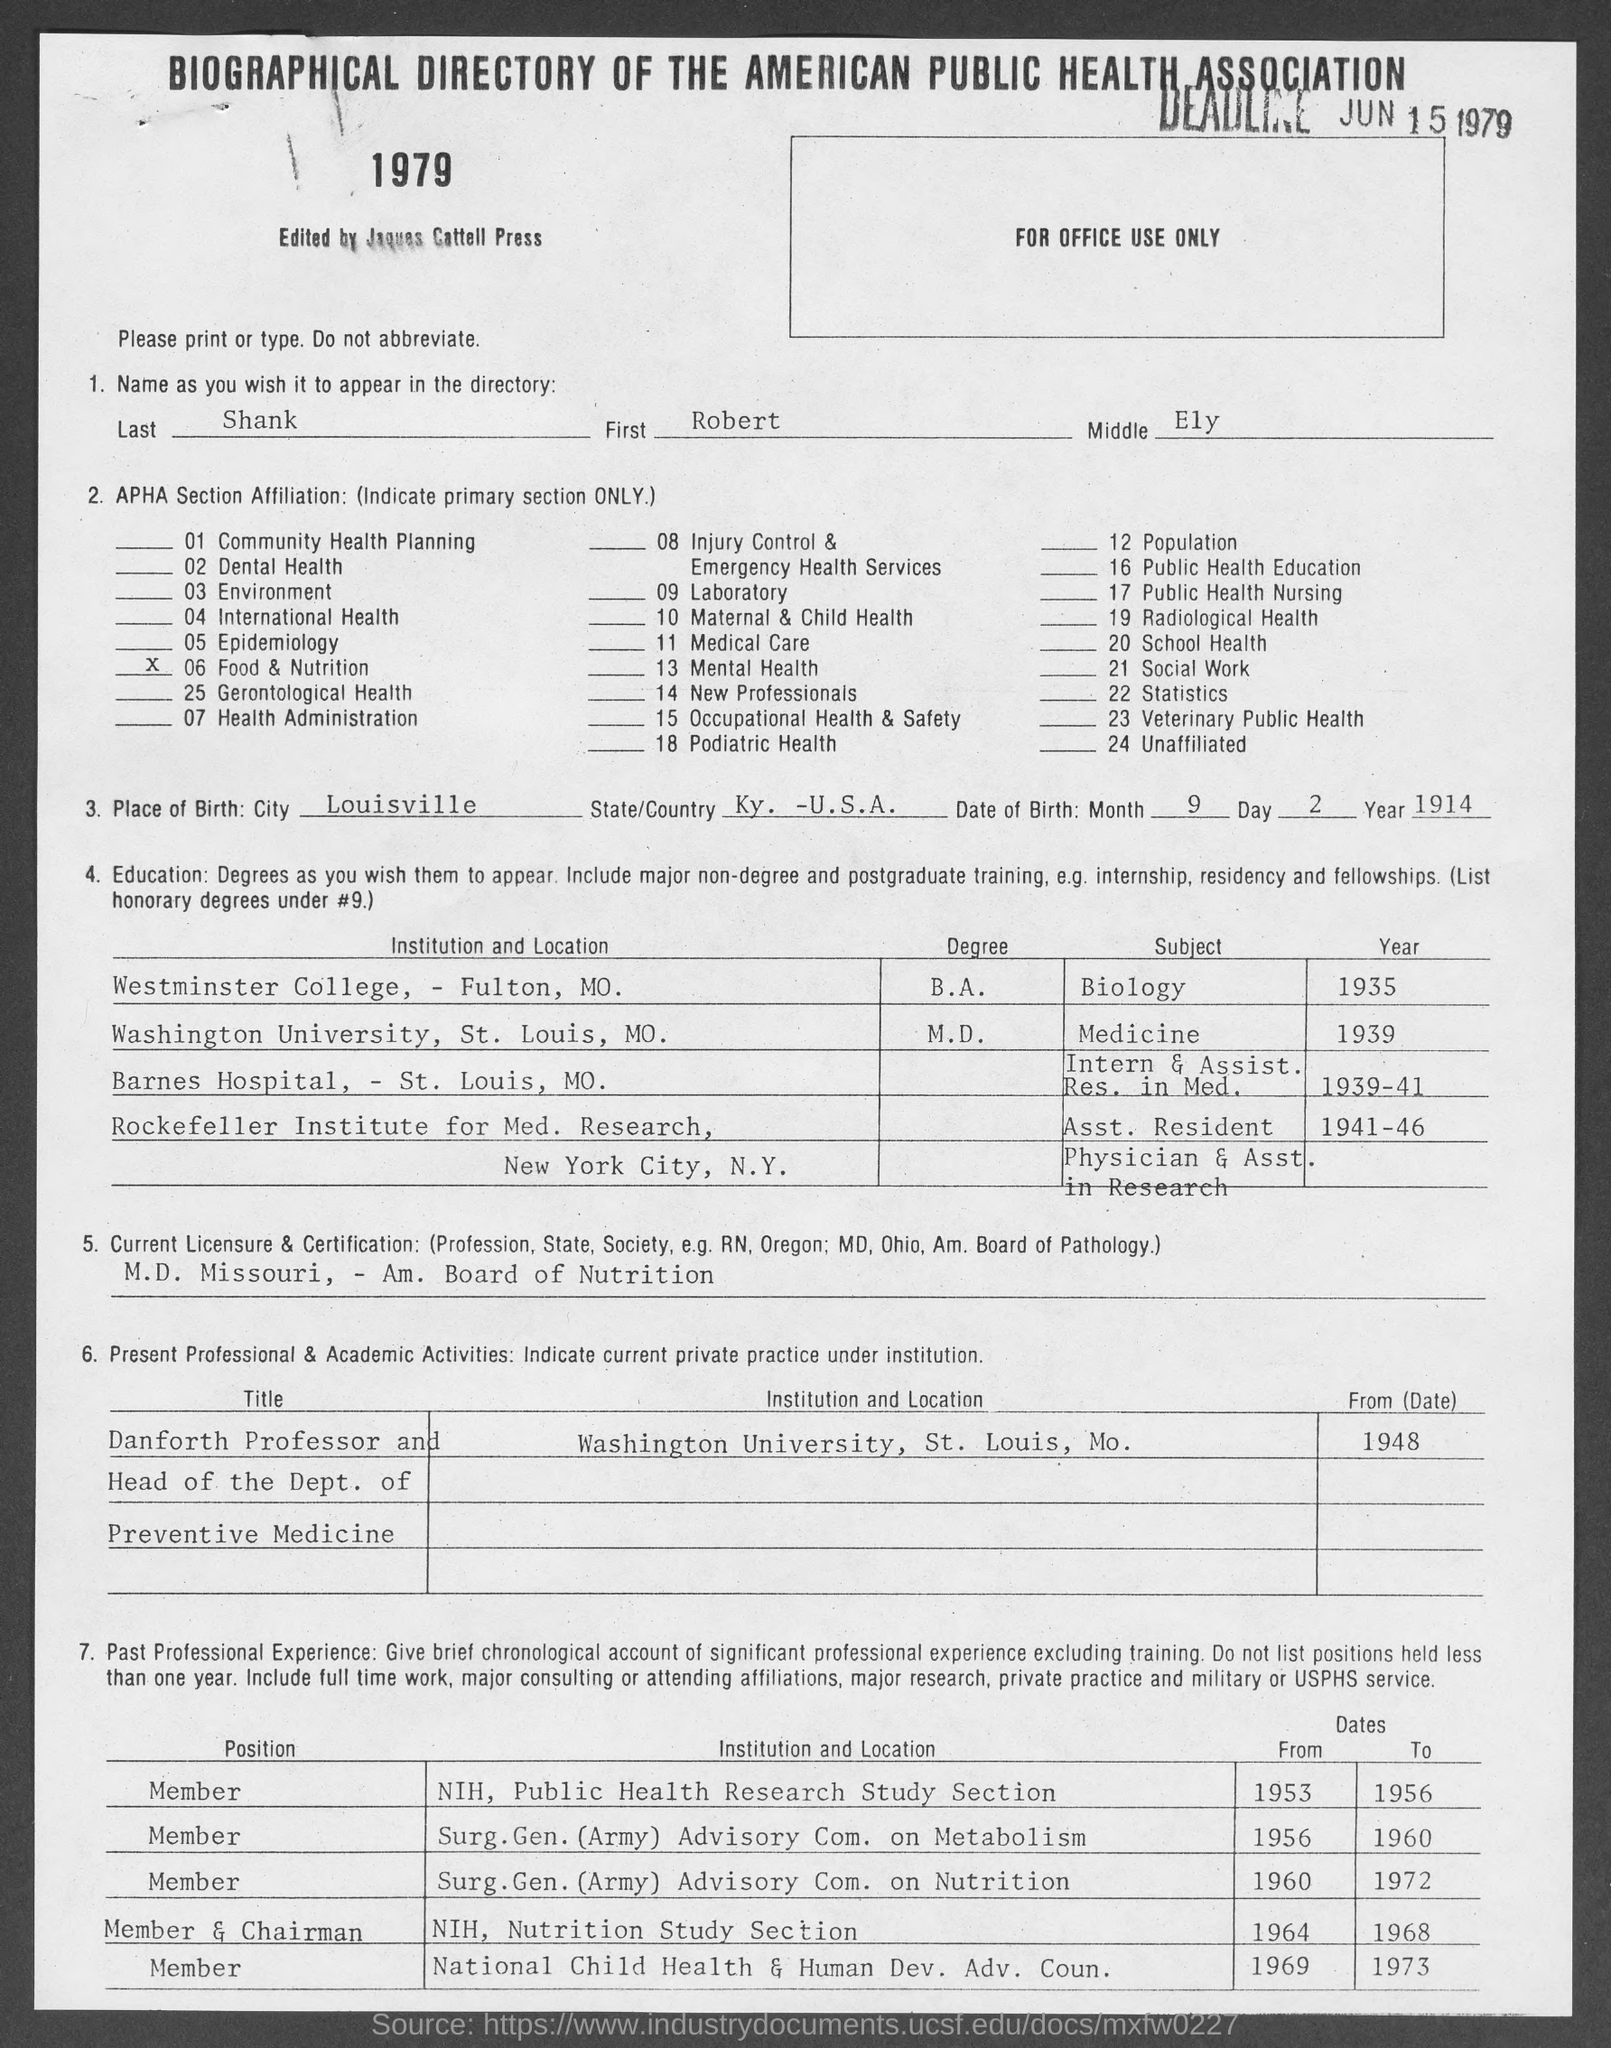List a handful of essential elements in this visual. The last name is Shank. I, [Name], hold a current licensure as an M.D. from the state of Missouri and am certified by the American Board of Nutrition. Your middle name is Ely. The place of birth of the individual in question is Ky., which is a state located within the United States of America. In 1935, he was a student at Westminster College. 